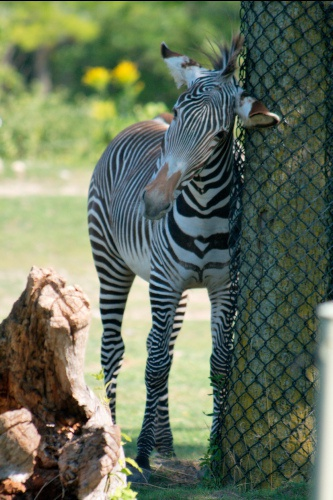Describe the objects in this image and their specific colors. I can see a zebra in black, gray, and blue tones in this image. 